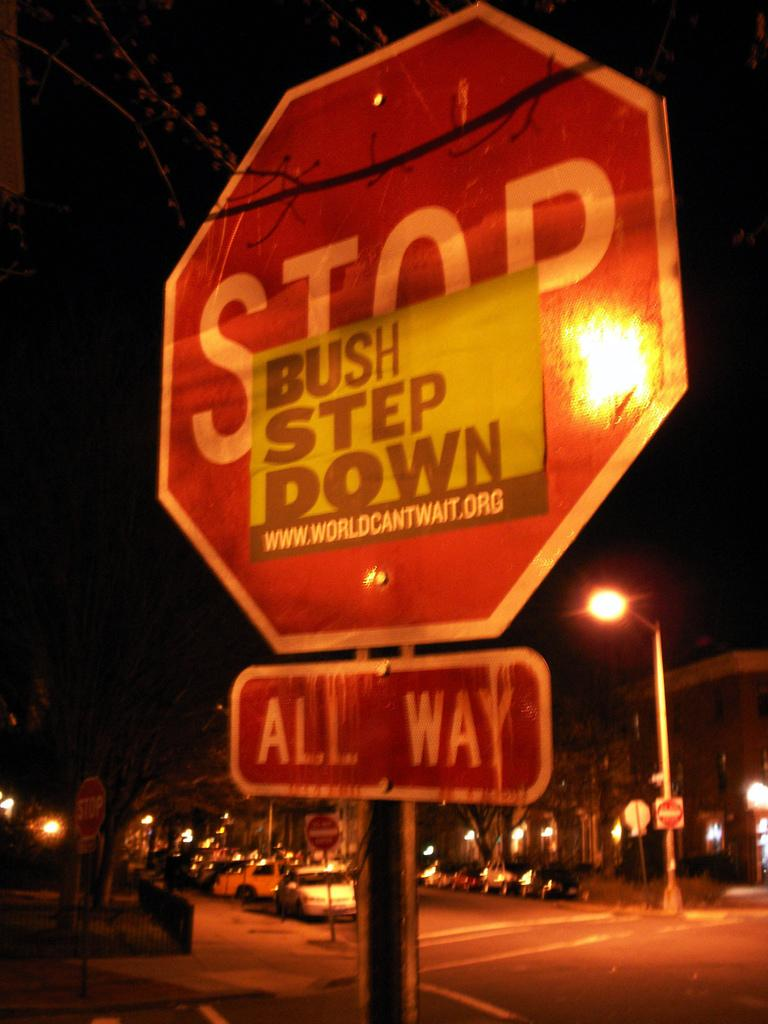<image>
Summarize the visual content of the image. A 'Bush Step Down' poster has been put on a Stop sign. 